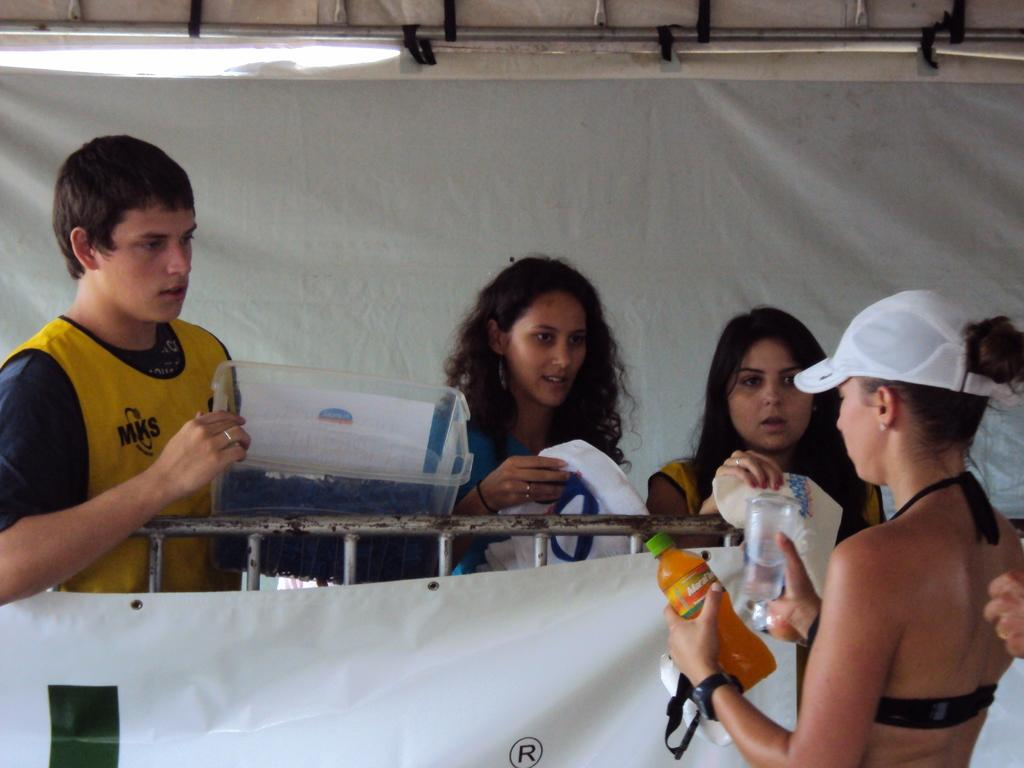Who is present in the image? There are people in the image. What is the woman holding in the image? The woman is holding juice bottles and glasses. What can be seen in the background of the image? There is a banner in the image. What is the man holding in the image? The man is holding a container. What type of basin is visible in the image? There is no basin present in the image. How many plates are stacked on the table in the image? There is no plate visible in the image. 